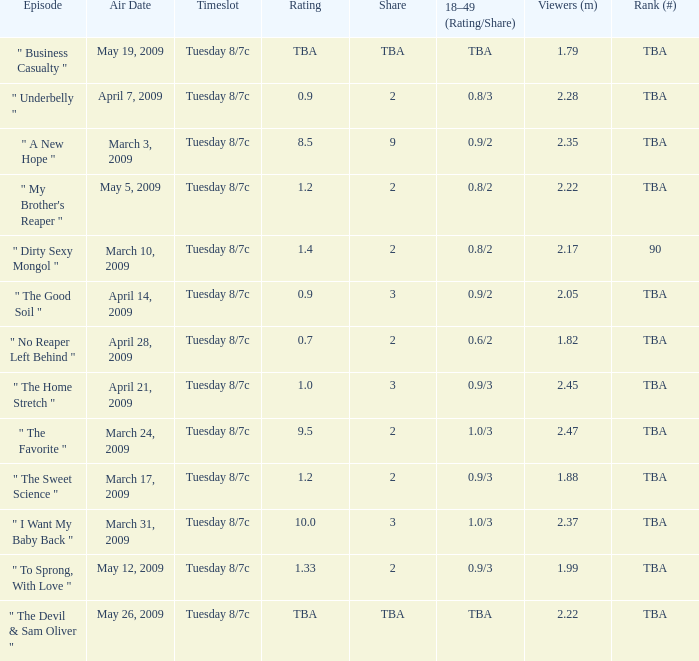What is the timeslot for the episode that aired April 28, 2009? Tuesday 8/7c. 